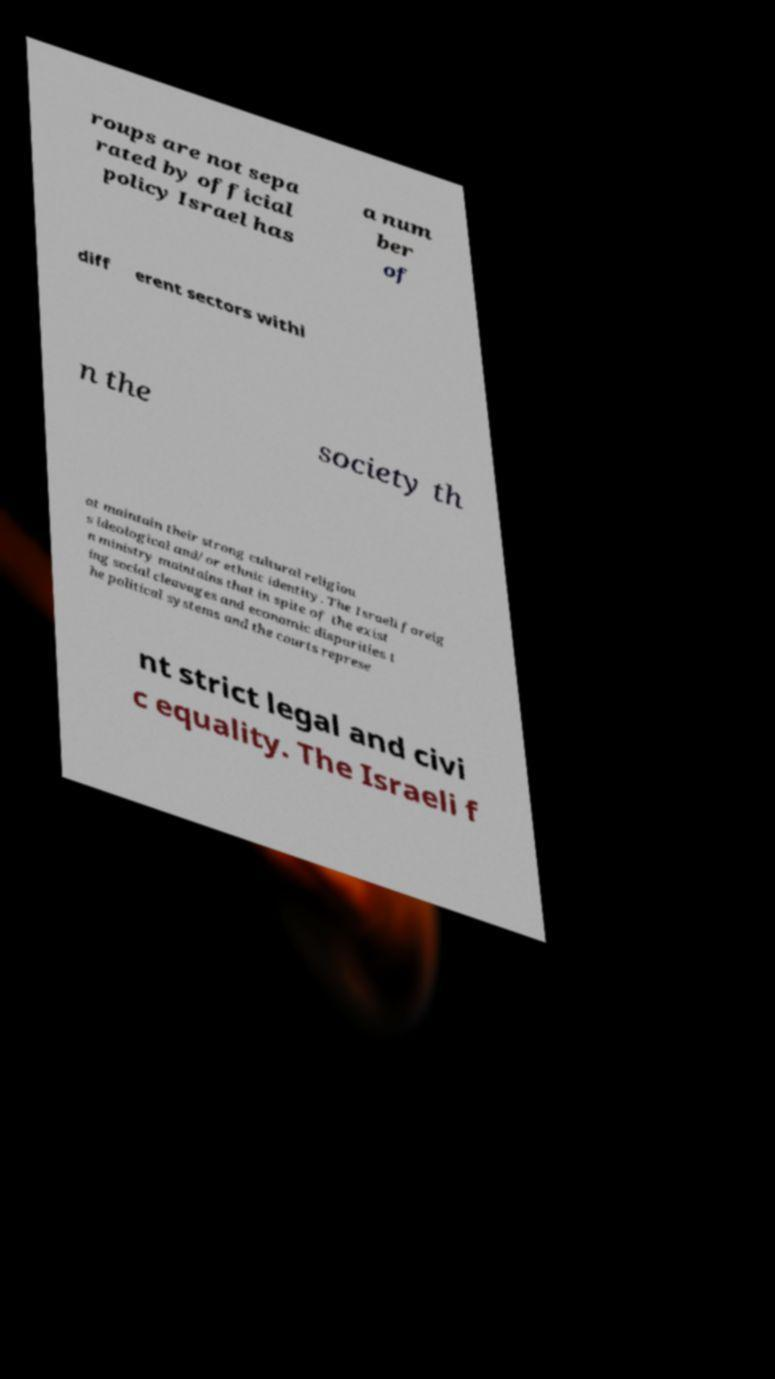I need the written content from this picture converted into text. Can you do that? roups are not sepa rated by official policy Israel has a num ber of diff erent sectors withi n the society th at maintain their strong cultural religiou s ideological and/or ethnic identity. The Israeli foreig n ministry maintains that in spite of the exist ing social cleavages and economic disparities t he political systems and the courts represe nt strict legal and civi c equality. The Israeli f 